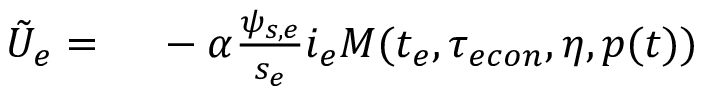Convert formula to latex. <formula><loc_0><loc_0><loc_500><loc_500>\begin{array} { r l } { \tilde { U } _ { e } = } & \ - \alpha \frac { \psi _ { s , e } } { s _ { e } } i _ { e } M ( t _ { e } , { \tau _ { e c o n } } , \eta , p ( t ) ) } \end{array}</formula> 